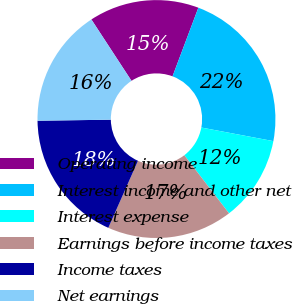Convert chart to OTSL. <chart><loc_0><loc_0><loc_500><loc_500><pie_chart><fcel>Operating income<fcel>Interest income and other net<fcel>Interest expense<fcel>Earnings before income taxes<fcel>Income taxes<fcel>Net earnings<nl><fcel>14.94%<fcel>22.24%<fcel>11.59%<fcel>17.07%<fcel>18.14%<fcel>16.01%<nl></chart> 